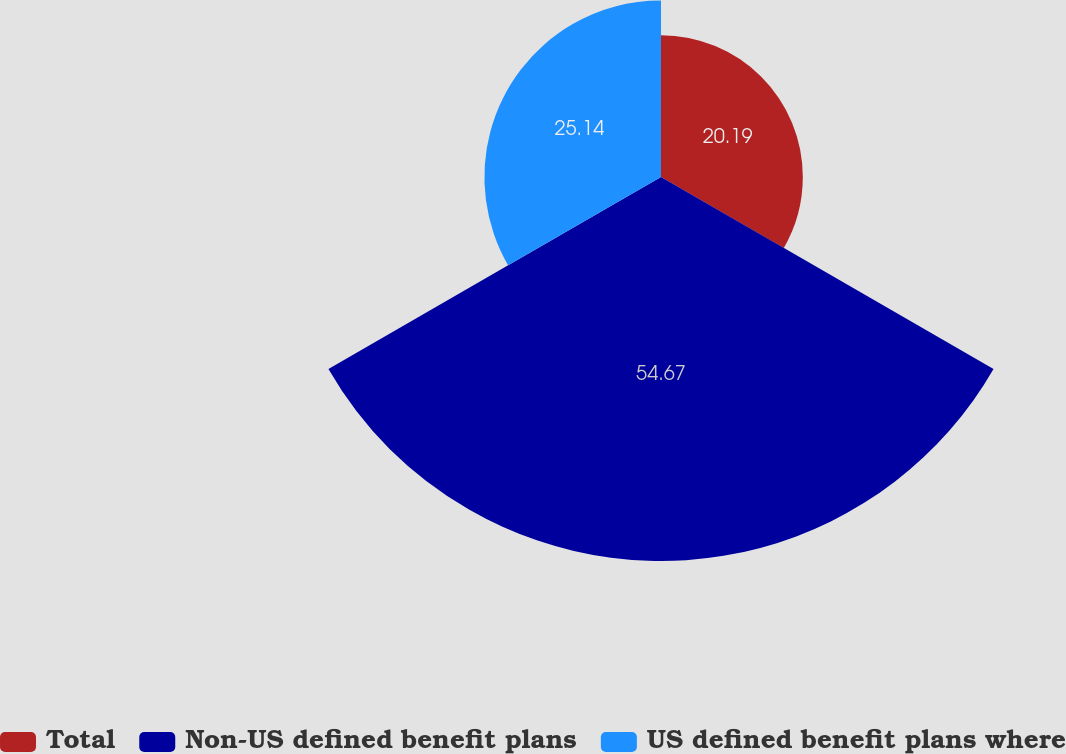Convert chart to OTSL. <chart><loc_0><loc_0><loc_500><loc_500><pie_chart><fcel>Total<fcel>Non-US defined benefit plans<fcel>US defined benefit plans where<nl><fcel>20.19%<fcel>54.67%<fcel>25.14%<nl></chart> 